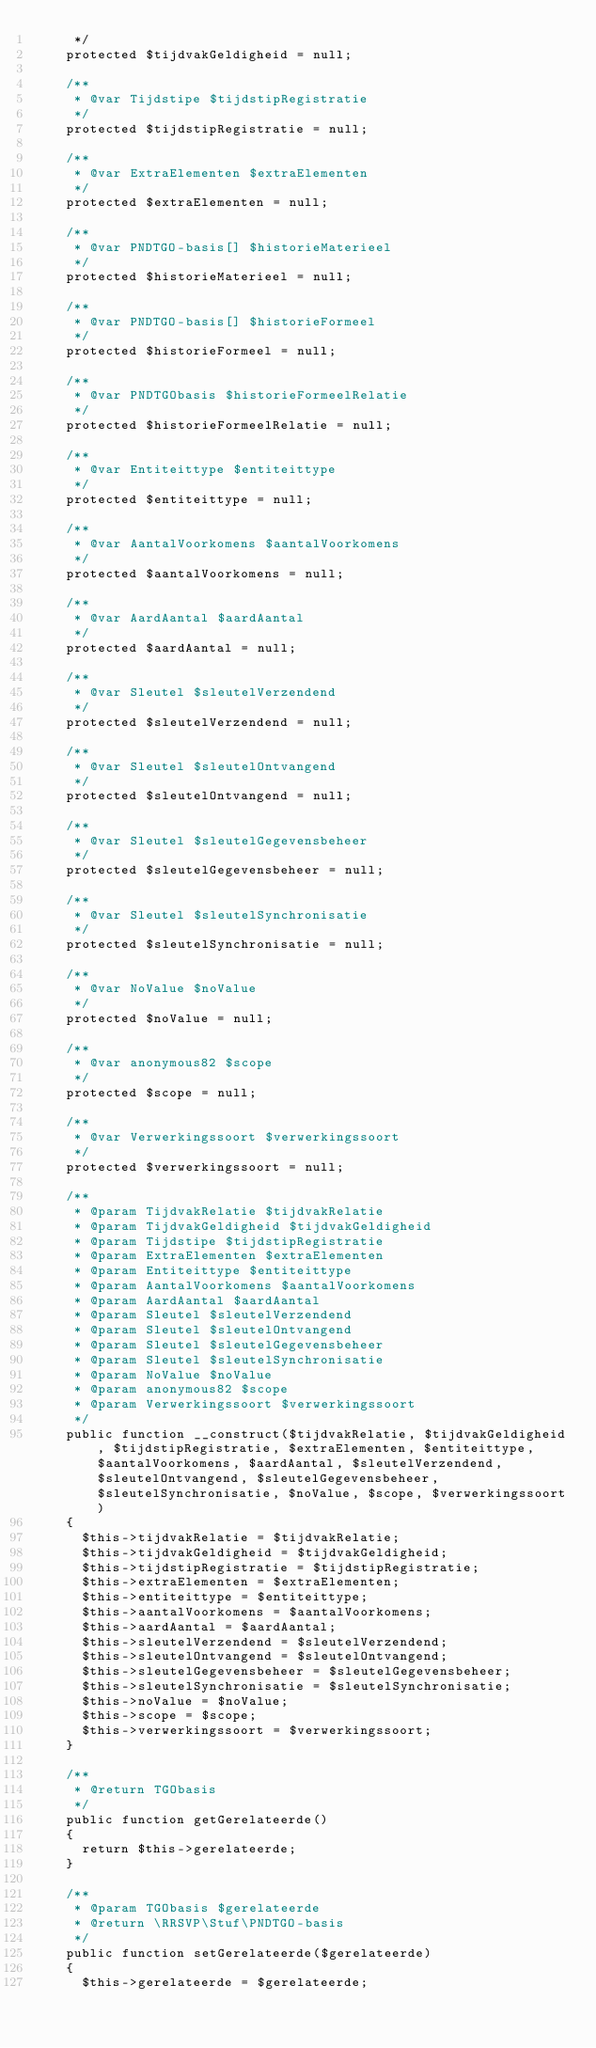<code> <loc_0><loc_0><loc_500><loc_500><_PHP_>     */
    protected $tijdvakGeldigheid = null;

    /**
     * @var Tijdstipe $tijdstipRegistratie
     */
    protected $tijdstipRegistratie = null;

    /**
     * @var ExtraElementen $extraElementen
     */
    protected $extraElementen = null;

    /**
     * @var PNDTGO-basis[] $historieMaterieel
     */
    protected $historieMaterieel = null;

    /**
     * @var PNDTGO-basis[] $historieFormeel
     */
    protected $historieFormeel = null;

    /**
     * @var PNDTGObasis $historieFormeelRelatie
     */
    protected $historieFormeelRelatie = null;

    /**
     * @var Entiteittype $entiteittype
     */
    protected $entiteittype = null;

    /**
     * @var AantalVoorkomens $aantalVoorkomens
     */
    protected $aantalVoorkomens = null;

    /**
     * @var AardAantal $aardAantal
     */
    protected $aardAantal = null;

    /**
     * @var Sleutel $sleutelVerzendend
     */
    protected $sleutelVerzendend = null;

    /**
     * @var Sleutel $sleutelOntvangend
     */
    protected $sleutelOntvangend = null;

    /**
     * @var Sleutel $sleutelGegevensbeheer
     */
    protected $sleutelGegevensbeheer = null;

    /**
     * @var Sleutel $sleutelSynchronisatie
     */
    protected $sleutelSynchronisatie = null;

    /**
     * @var NoValue $noValue
     */
    protected $noValue = null;

    /**
     * @var anonymous82 $scope
     */
    protected $scope = null;

    /**
     * @var Verwerkingssoort $verwerkingssoort
     */
    protected $verwerkingssoort = null;

    /**
     * @param TijdvakRelatie $tijdvakRelatie
     * @param TijdvakGeldigheid $tijdvakGeldigheid
     * @param Tijdstipe $tijdstipRegistratie
     * @param ExtraElementen $extraElementen
     * @param Entiteittype $entiteittype
     * @param AantalVoorkomens $aantalVoorkomens
     * @param AardAantal $aardAantal
     * @param Sleutel $sleutelVerzendend
     * @param Sleutel $sleutelOntvangend
     * @param Sleutel $sleutelGegevensbeheer
     * @param Sleutel $sleutelSynchronisatie
     * @param NoValue $noValue
     * @param anonymous82 $scope
     * @param Verwerkingssoort $verwerkingssoort
     */
    public function __construct($tijdvakRelatie, $tijdvakGeldigheid, $tijdstipRegistratie, $extraElementen, $entiteittype, $aantalVoorkomens, $aardAantal, $sleutelVerzendend, $sleutelOntvangend, $sleutelGegevensbeheer, $sleutelSynchronisatie, $noValue, $scope, $verwerkingssoort)
    {
      $this->tijdvakRelatie = $tijdvakRelatie;
      $this->tijdvakGeldigheid = $tijdvakGeldigheid;
      $this->tijdstipRegistratie = $tijdstipRegistratie;
      $this->extraElementen = $extraElementen;
      $this->entiteittype = $entiteittype;
      $this->aantalVoorkomens = $aantalVoorkomens;
      $this->aardAantal = $aardAantal;
      $this->sleutelVerzendend = $sleutelVerzendend;
      $this->sleutelOntvangend = $sleutelOntvangend;
      $this->sleutelGegevensbeheer = $sleutelGegevensbeheer;
      $this->sleutelSynchronisatie = $sleutelSynchronisatie;
      $this->noValue = $noValue;
      $this->scope = $scope;
      $this->verwerkingssoort = $verwerkingssoort;
    }

    /**
     * @return TGObasis
     */
    public function getGerelateerde()
    {
      return $this->gerelateerde;
    }

    /**
     * @param TGObasis $gerelateerde
     * @return \RRSVP\Stuf\PNDTGO-basis
     */
    public function setGerelateerde($gerelateerde)
    {
      $this->gerelateerde = $gerelateerde;</code> 